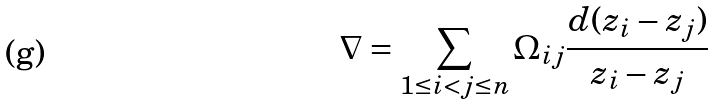<formula> <loc_0><loc_0><loc_500><loc_500>\nabla = \sum _ { 1 \leq i < j \leq n } \Omega _ { i j } \frac { d ( z _ { i } - z _ { j } ) } { z _ { i } - z _ { j } }</formula> 